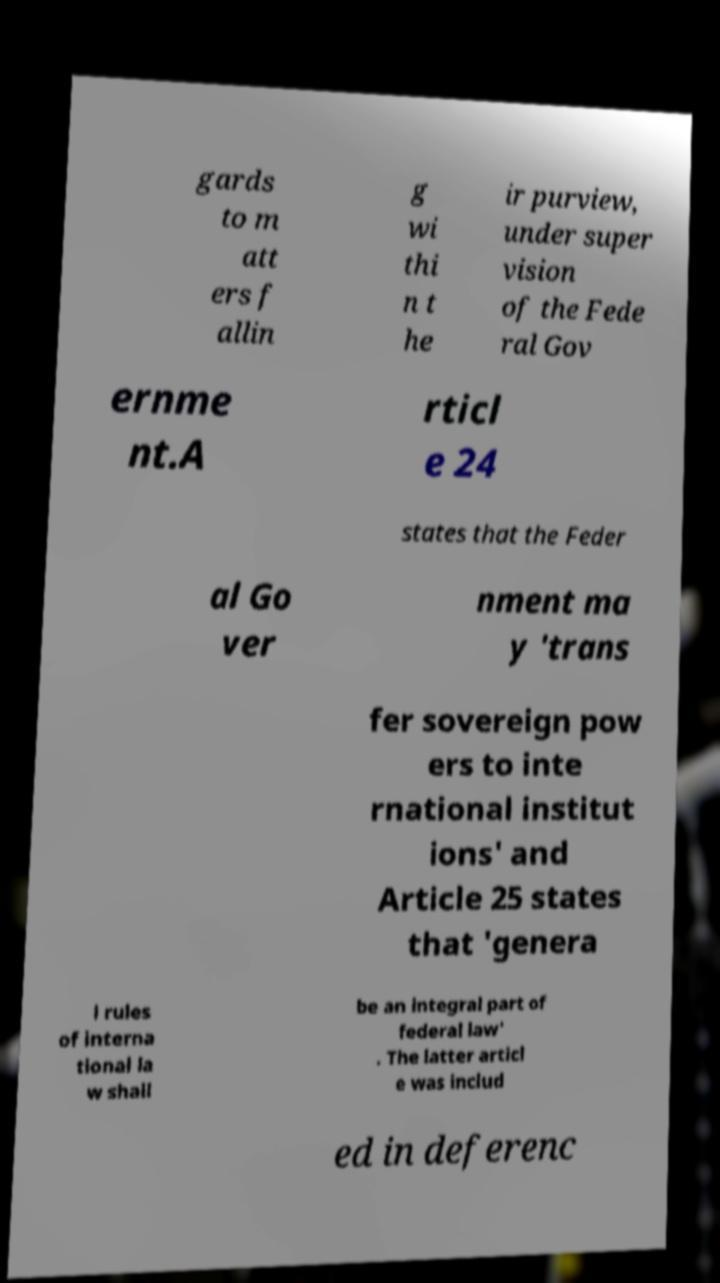Can you read and provide the text displayed in the image?This photo seems to have some interesting text. Can you extract and type it out for me? gards to m att ers f allin g wi thi n t he ir purview, under super vision of the Fede ral Gov ernme nt.A rticl e 24 states that the Feder al Go ver nment ma y 'trans fer sovereign pow ers to inte rnational institut ions' and Article 25 states that 'genera l rules of interna tional la w shall be an integral part of federal law' . The latter articl e was includ ed in deferenc 